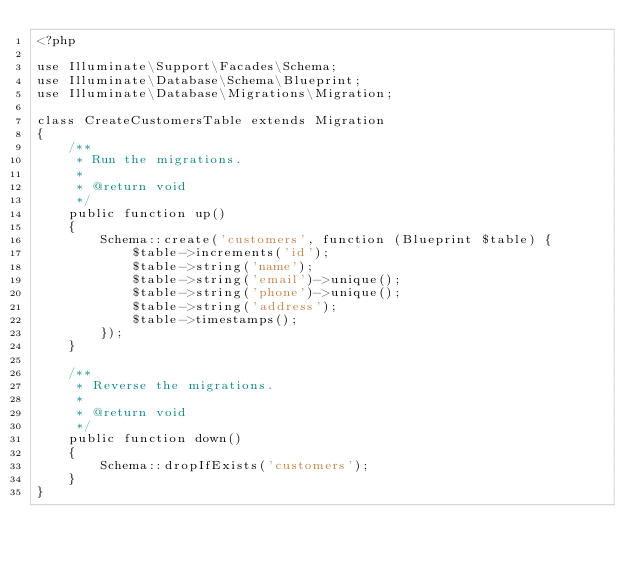Convert code to text. <code><loc_0><loc_0><loc_500><loc_500><_PHP_><?php

use Illuminate\Support\Facades\Schema;
use Illuminate\Database\Schema\Blueprint;
use Illuminate\Database\Migrations\Migration;

class CreateCustomersTable extends Migration
{
    /**
     * Run the migrations.
     *
     * @return void
     */
    public function up()
    {
        Schema::create('customers', function (Blueprint $table) {
            $table->increments('id');
            $table->string('name');
            $table->string('email')->unique();
            $table->string('phone')->unique();
            $table->string('address');
            $table->timestamps();
        });
    }

    /**
     * Reverse the migrations.
     *
     * @return void
     */
    public function down()
    {
        Schema::dropIfExists('customers');
    }
}
</code> 